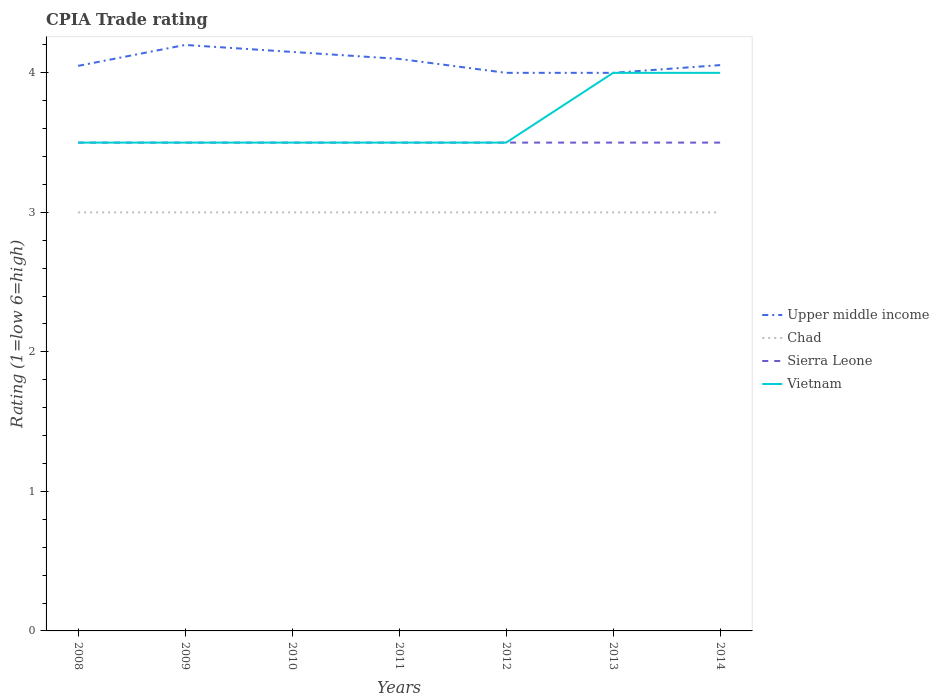Does the line corresponding to Chad intersect with the line corresponding to Upper middle income?
Your response must be concise. No. In which year was the CPIA rating in Upper middle income maximum?
Make the answer very short. 2012. What is the difference between the highest and the second highest CPIA rating in Upper middle income?
Provide a succinct answer. 0.2. What is the difference between the highest and the lowest CPIA rating in Vietnam?
Provide a succinct answer. 2. Is the CPIA rating in Upper middle income strictly greater than the CPIA rating in Chad over the years?
Your answer should be very brief. No. How many lines are there?
Keep it short and to the point. 4. How many years are there in the graph?
Give a very brief answer. 7. What is the difference between two consecutive major ticks on the Y-axis?
Make the answer very short. 1. Are the values on the major ticks of Y-axis written in scientific E-notation?
Offer a terse response. No. How are the legend labels stacked?
Your answer should be very brief. Vertical. What is the title of the graph?
Provide a succinct answer. CPIA Trade rating. Does "Mexico" appear as one of the legend labels in the graph?
Your answer should be compact. No. What is the Rating (1=low 6=high) of Upper middle income in 2008?
Offer a terse response. 4.05. What is the Rating (1=low 6=high) in Vietnam in 2008?
Your response must be concise. 3.5. What is the Rating (1=low 6=high) of Chad in 2009?
Offer a terse response. 3. What is the Rating (1=low 6=high) of Sierra Leone in 2009?
Provide a short and direct response. 3.5. What is the Rating (1=low 6=high) in Upper middle income in 2010?
Ensure brevity in your answer.  4.15. What is the Rating (1=low 6=high) of Sierra Leone in 2010?
Make the answer very short. 3.5. What is the Rating (1=low 6=high) of Vietnam in 2010?
Provide a succinct answer. 3.5. What is the Rating (1=low 6=high) of Chad in 2011?
Give a very brief answer. 3. What is the Rating (1=low 6=high) in Sierra Leone in 2011?
Give a very brief answer. 3.5. What is the Rating (1=low 6=high) in Sierra Leone in 2012?
Provide a short and direct response. 3.5. What is the Rating (1=low 6=high) of Vietnam in 2012?
Your response must be concise. 3.5. What is the Rating (1=low 6=high) of Sierra Leone in 2013?
Your answer should be compact. 3.5. What is the Rating (1=low 6=high) of Upper middle income in 2014?
Ensure brevity in your answer.  4.06. What is the Rating (1=low 6=high) of Chad in 2014?
Your answer should be compact. 3. What is the Rating (1=low 6=high) in Vietnam in 2014?
Ensure brevity in your answer.  4. Across all years, what is the maximum Rating (1=low 6=high) in Upper middle income?
Your answer should be compact. 4.2. Across all years, what is the maximum Rating (1=low 6=high) of Vietnam?
Your response must be concise. 4. Across all years, what is the minimum Rating (1=low 6=high) of Chad?
Your answer should be very brief. 3. Across all years, what is the minimum Rating (1=low 6=high) in Vietnam?
Offer a very short reply. 3.5. What is the total Rating (1=low 6=high) of Upper middle income in the graph?
Provide a short and direct response. 28.56. What is the total Rating (1=low 6=high) in Chad in the graph?
Provide a short and direct response. 21. What is the total Rating (1=low 6=high) of Sierra Leone in the graph?
Your response must be concise. 24.5. What is the total Rating (1=low 6=high) in Vietnam in the graph?
Provide a succinct answer. 25.5. What is the difference between the Rating (1=low 6=high) of Upper middle income in 2008 and that in 2009?
Ensure brevity in your answer.  -0.15. What is the difference between the Rating (1=low 6=high) in Chad in 2008 and that in 2009?
Offer a terse response. 0. What is the difference between the Rating (1=low 6=high) of Upper middle income in 2008 and that in 2011?
Your answer should be compact. -0.05. What is the difference between the Rating (1=low 6=high) of Chad in 2008 and that in 2011?
Your answer should be compact. 0. What is the difference between the Rating (1=low 6=high) in Vietnam in 2008 and that in 2011?
Your answer should be compact. 0. What is the difference between the Rating (1=low 6=high) of Chad in 2008 and that in 2012?
Your response must be concise. 0. What is the difference between the Rating (1=low 6=high) of Upper middle income in 2008 and that in 2014?
Provide a succinct answer. -0.01. What is the difference between the Rating (1=low 6=high) in Vietnam in 2008 and that in 2014?
Keep it short and to the point. -0.5. What is the difference between the Rating (1=low 6=high) of Chad in 2009 and that in 2010?
Offer a terse response. 0. What is the difference between the Rating (1=low 6=high) in Sierra Leone in 2009 and that in 2010?
Make the answer very short. 0. What is the difference between the Rating (1=low 6=high) of Upper middle income in 2009 and that in 2011?
Ensure brevity in your answer.  0.1. What is the difference between the Rating (1=low 6=high) of Vietnam in 2009 and that in 2011?
Your answer should be compact. 0. What is the difference between the Rating (1=low 6=high) in Upper middle income in 2009 and that in 2012?
Your answer should be compact. 0.2. What is the difference between the Rating (1=low 6=high) of Chad in 2009 and that in 2012?
Offer a very short reply. 0. What is the difference between the Rating (1=low 6=high) of Vietnam in 2009 and that in 2012?
Provide a succinct answer. 0. What is the difference between the Rating (1=low 6=high) in Upper middle income in 2009 and that in 2013?
Offer a very short reply. 0.2. What is the difference between the Rating (1=low 6=high) in Chad in 2009 and that in 2013?
Offer a terse response. 0. What is the difference between the Rating (1=low 6=high) of Sierra Leone in 2009 and that in 2013?
Make the answer very short. 0. What is the difference between the Rating (1=low 6=high) of Vietnam in 2009 and that in 2013?
Give a very brief answer. -0.5. What is the difference between the Rating (1=low 6=high) of Upper middle income in 2009 and that in 2014?
Ensure brevity in your answer.  0.14. What is the difference between the Rating (1=low 6=high) of Chad in 2009 and that in 2014?
Ensure brevity in your answer.  0. What is the difference between the Rating (1=low 6=high) in Chad in 2010 and that in 2011?
Offer a terse response. 0. What is the difference between the Rating (1=low 6=high) of Sierra Leone in 2010 and that in 2011?
Offer a terse response. 0. What is the difference between the Rating (1=low 6=high) of Vietnam in 2010 and that in 2011?
Give a very brief answer. 0. What is the difference between the Rating (1=low 6=high) in Vietnam in 2010 and that in 2012?
Your response must be concise. 0. What is the difference between the Rating (1=low 6=high) of Sierra Leone in 2010 and that in 2013?
Provide a short and direct response. 0. What is the difference between the Rating (1=low 6=high) of Vietnam in 2010 and that in 2013?
Provide a short and direct response. -0.5. What is the difference between the Rating (1=low 6=high) of Upper middle income in 2010 and that in 2014?
Your answer should be very brief. 0.09. What is the difference between the Rating (1=low 6=high) of Sierra Leone in 2010 and that in 2014?
Make the answer very short. 0. What is the difference between the Rating (1=low 6=high) of Vietnam in 2010 and that in 2014?
Your answer should be very brief. -0.5. What is the difference between the Rating (1=low 6=high) of Upper middle income in 2011 and that in 2012?
Offer a very short reply. 0.1. What is the difference between the Rating (1=low 6=high) in Chad in 2011 and that in 2013?
Ensure brevity in your answer.  0. What is the difference between the Rating (1=low 6=high) in Upper middle income in 2011 and that in 2014?
Offer a very short reply. 0.04. What is the difference between the Rating (1=low 6=high) of Chad in 2011 and that in 2014?
Your response must be concise. 0. What is the difference between the Rating (1=low 6=high) in Sierra Leone in 2011 and that in 2014?
Provide a short and direct response. 0. What is the difference between the Rating (1=low 6=high) in Vietnam in 2011 and that in 2014?
Keep it short and to the point. -0.5. What is the difference between the Rating (1=low 6=high) of Upper middle income in 2012 and that in 2013?
Provide a succinct answer. 0. What is the difference between the Rating (1=low 6=high) of Chad in 2012 and that in 2013?
Your answer should be compact. 0. What is the difference between the Rating (1=low 6=high) in Sierra Leone in 2012 and that in 2013?
Give a very brief answer. 0. What is the difference between the Rating (1=low 6=high) of Upper middle income in 2012 and that in 2014?
Provide a short and direct response. -0.06. What is the difference between the Rating (1=low 6=high) of Upper middle income in 2013 and that in 2014?
Offer a terse response. -0.06. What is the difference between the Rating (1=low 6=high) of Chad in 2013 and that in 2014?
Make the answer very short. 0. What is the difference between the Rating (1=low 6=high) in Sierra Leone in 2013 and that in 2014?
Offer a terse response. 0. What is the difference between the Rating (1=low 6=high) in Vietnam in 2013 and that in 2014?
Your answer should be very brief. 0. What is the difference between the Rating (1=low 6=high) of Upper middle income in 2008 and the Rating (1=low 6=high) of Chad in 2009?
Provide a short and direct response. 1.05. What is the difference between the Rating (1=low 6=high) of Upper middle income in 2008 and the Rating (1=low 6=high) of Sierra Leone in 2009?
Provide a short and direct response. 0.55. What is the difference between the Rating (1=low 6=high) of Upper middle income in 2008 and the Rating (1=low 6=high) of Vietnam in 2009?
Provide a short and direct response. 0.55. What is the difference between the Rating (1=low 6=high) in Upper middle income in 2008 and the Rating (1=low 6=high) in Chad in 2010?
Offer a terse response. 1.05. What is the difference between the Rating (1=low 6=high) in Upper middle income in 2008 and the Rating (1=low 6=high) in Sierra Leone in 2010?
Offer a very short reply. 0.55. What is the difference between the Rating (1=low 6=high) in Upper middle income in 2008 and the Rating (1=low 6=high) in Vietnam in 2010?
Give a very brief answer. 0.55. What is the difference between the Rating (1=low 6=high) of Upper middle income in 2008 and the Rating (1=low 6=high) of Sierra Leone in 2011?
Provide a succinct answer. 0.55. What is the difference between the Rating (1=low 6=high) of Upper middle income in 2008 and the Rating (1=low 6=high) of Vietnam in 2011?
Offer a terse response. 0.55. What is the difference between the Rating (1=low 6=high) in Chad in 2008 and the Rating (1=low 6=high) in Sierra Leone in 2011?
Provide a short and direct response. -0.5. What is the difference between the Rating (1=low 6=high) of Upper middle income in 2008 and the Rating (1=low 6=high) of Sierra Leone in 2012?
Your answer should be compact. 0.55. What is the difference between the Rating (1=low 6=high) in Upper middle income in 2008 and the Rating (1=low 6=high) in Vietnam in 2012?
Offer a very short reply. 0.55. What is the difference between the Rating (1=low 6=high) of Chad in 2008 and the Rating (1=low 6=high) of Sierra Leone in 2012?
Your answer should be compact. -0.5. What is the difference between the Rating (1=low 6=high) of Upper middle income in 2008 and the Rating (1=low 6=high) of Sierra Leone in 2013?
Make the answer very short. 0.55. What is the difference between the Rating (1=low 6=high) in Upper middle income in 2008 and the Rating (1=low 6=high) in Vietnam in 2013?
Your answer should be very brief. 0.05. What is the difference between the Rating (1=low 6=high) of Chad in 2008 and the Rating (1=low 6=high) of Sierra Leone in 2013?
Your answer should be very brief. -0.5. What is the difference between the Rating (1=low 6=high) in Chad in 2008 and the Rating (1=low 6=high) in Vietnam in 2013?
Your response must be concise. -1. What is the difference between the Rating (1=low 6=high) of Upper middle income in 2008 and the Rating (1=low 6=high) of Sierra Leone in 2014?
Make the answer very short. 0.55. What is the difference between the Rating (1=low 6=high) of Chad in 2008 and the Rating (1=low 6=high) of Sierra Leone in 2014?
Ensure brevity in your answer.  -0.5. What is the difference between the Rating (1=low 6=high) in Sierra Leone in 2008 and the Rating (1=low 6=high) in Vietnam in 2014?
Provide a short and direct response. -0.5. What is the difference between the Rating (1=low 6=high) in Upper middle income in 2009 and the Rating (1=low 6=high) in Sierra Leone in 2010?
Ensure brevity in your answer.  0.7. What is the difference between the Rating (1=low 6=high) of Chad in 2009 and the Rating (1=low 6=high) of Sierra Leone in 2010?
Your answer should be compact. -0.5. What is the difference between the Rating (1=low 6=high) in Chad in 2009 and the Rating (1=low 6=high) in Vietnam in 2010?
Your answer should be compact. -0.5. What is the difference between the Rating (1=low 6=high) of Upper middle income in 2009 and the Rating (1=low 6=high) of Chad in 2011?
Keep it short and to the point. 1.2. What is the difference between the Rating (1=low 6=high) in Upper middle income in 2009 and the Rating (1=low 6=high) in Sierra Leone in 2011?
Your response must be concise. 0.7. What is the difference between the Rating (1=low 6=high) in Sierra Leone in 2009 and the Rating (1=low 6=high) in Vietnam in 2011?
Provide a short and direct response. 0. What is the difference between the Rating (1=low 6=high) of Upper middle income in 2009 and the Rating (1=low 6=high) of Vietnam in 2012?
Your answer should be very brief. 0.7. What is the difference between the Rating (1=low 6=high) of Chad in 2009 and the Rating (1=low 6=high) of Vietnam in 2012?
Make the answer very short. -0.5. What is the difference between the Rating (1=low 6=high) of Sierra Leone in 2009 and the Rating (1=low 6=high) of Vietnam in 2012?
Your answer should be compact. 0. What is the difference between the Rating (1=low 6=high) of Upper middle income in 2009 and the Rating (1=low 6=high) of Sierra Leone in 2013?
Make the answer very short. 0.7. What is the difference between the Rating (1=low 6=high) of Upper middle income in 2009 and the Rating (1=low 6=high) of Vietnam in 2013?
Offer a terse response. 0.2. What is the difference between the Rating (1=low 6=high) of Sierra Leone in 2009 and the Rating (1=low 6=high) of Vietnam in 2013?
Give a very brief answer. -0.5. What is the difference between the Rating (1=low 6=high) in Upper middle income in 2009 and the Rating (1=low 6=high) in Sierra Leone in 2014?
Your response must be concise. 0.7. What is the difference between the Rating (1=low 6=high) of Upper middle income in 2010 and the Rating (1=low 6=high) of Chad in 2011?
Offer a terse response. 1.15. What is the difference between the Rating (1=low 6=high) of Upper middle income in 2010 and the Rating (1=low 6=high) of Sierra Leone in 2011?
Give a very brief answer. 0.65. What is the difference between the Rating (1=low 6=high) of Upper middle income in 2010 and the Rating (1=low 6=high) of Vietnam in 2011?
Provide a succinct answer. 0.65. What is the difference between the Rating (1=low 6=high) of Chad in 2010 and the Rating (1=low 6=high) of Vietnam in 2011?
Keep it short and to the point. -0.5. What is the difference between the Rating (1=low 6=high) in Upper middle income in 2010 and the Rating (1=low 6=high) in Chad in 2012?
Keep it short and to the point. 1.15. What is the difference between the Rating (1=low 6=high) of Upper middle income in 2010 and the Rating (1=low 6=high) of Sierra Leone in 2012?
Provide a short and direct response. 0.65. What is the difference between the Rating (1=low 6=high) in Upper middle income in 2010 and the Rating (1=low 6=high) in Vietnam in 2012?
Provide a short and direct response. 0.65. What is the difference between the Rating (1=low 6=high) of Upper middle income in 2010 and the Rating (1=low 6=high) of Chad in 2013?
Your response must be concise. 1.15. What is the difference between the Rating (1=low 6=high) of Upper middle income in 2010 and the Rating (1=low 6=high) of Sierra Leone in 2013?
Provide a short and direct response. 0.65. What is the difference between the Rating (1=low 6=high) of Upper middle income in 2010 and the Rating (1=low 6=high) of Chad in 2014?
Offer a very short reply. 1.15. What is the difference between the Rating (1=low 6=high) of Upper middle income in 2010 and the Rating (1=low 6=high) of Sierra Leone in 2014?
Ensure brevity in your answer.  0.65. What is the difference between the Rating (1=low 6=high) in Upper middle income in 2010 and the Rating (1=low 6=high) in Vietnam in 2014?
Your answer should be compact. 0.15. What is the difference between the Rating (1=low 6=high) of Chad in 2010 and the Rating (1=low 6=high) of Vietnam in 2014?
Provide a succinct answer. -1. What is the difference between the Rating (1=low 6=high) of Upper middle income in 2011 and the Rating (1=low 6=high) of Vietnam in 2012?
Your answer should be very brief. 0.6. What is the difference between the Rating (1=low 6=high) in Upper middle income in 2011 and the Rating (1=low 6=high) in Chad in 2013?
Ensure brevity in your answer.  1.1. What is the difference between the Rating (1=low 6=high) in Upper middle income in 2011 and the Rating (1=low 6=high) in Sierra Leone in 2013?
Your answer should be compact. 0.6. What is the difference between the Rating (1=low 6=high) of Chad in 2011 and the Rating (1=low 6=high) of Sierra Leone in 2013?
Your response must be concise. -0.5. What is the difference between the Rating (1=low 6=high) of Chad in 2011 and the Rating (1=low 6=high) of Vietnam in 2013?
Offer a very short reply. -1. What is the difference between the Rating (1=low 6=high) of Upper middle income in 2011 and the Rating (1=low 6=high) of Chad in 2014?
Your response must be concise. 1.1. What is the difference between the Rating (1=low 6=high) of Upper middle income in 2011 and the Rating (1=low 6=high) of Vietnam in 2014?
Ensure brevity in your answer.  0.1. What is the difference between the Rating (1=low 6=high) in Chad in 2011 and the Rating (1=low 6=high) in Vietnam in 2014?
Your answer should be very brief. -1. What is the difference between the Rating (1=low 6=high) of Upper middle income in 2012 and the Rating (1=low 6=high) of Sierra Leone in 2013?
Your response must be concise. 0.5. What is the difference between the Rating (1=low 6=high) in Upper middle income in 2012 and the Rating (1=low 6=high) in Vietnam in 2013?
Keep it short and to the point. 0. What is the difference between the Rating (1=low 6=high) of Chad in 2012 and the Rating (1=low 6=high) of Sierra Leone in 2013?
Make the answer very short. -0.5. What is the difference between the Rating (1=low 6=high) of Sierra Leone in 2012 and the Rating (1=low 6=high) of Vietnam in 2013?
Provide a succinct answer. -0.5. What is the difference between the Rating (1=low 6=high) in Upper middle income in 2012 and the Rating (1=low 6=high) in Chad in 2014?
Ensure brevity in your answer.  1. What is the difference between the Rating (1=low 6=high) of Upper middle income in 2012 and the Rating (1=low 6=high) of Sierra Leone in 2014?
Offer a very short reply. 0.5. What is the difference between the Rating (1=low 6=high) in Upper middle income in 2012 and the Rating (1=low 6=high) in Vietnam in 2014?
Make the answer very short. 0. What is the difference between the Rating (1=low 6=high) in Chad in 2012 and the Rating (1=low 6=high) in Sierra Leone in 2014?
Your answer should be compact. -0.5. What is the difference between the Rating (1=low 6=high) of Upper middle income in 2013 and the Rating (1=low 6=high) of Sierra Leone in 2014?
Your answer should be very brief. 0.5. What is the difference between the Rating (1=low 6=high) in Chad in 2013 and the Rating (1=low 6=high) in Vietnam in 2014?
Your answer should be compact. -1. What is the average Rating (1=low 6=high) in Upper middle income per year?
Ensure brevity in your answer.  4.08. What is the average Rating (1=low 6=high) of Sierra Leone per year?
Give a very brief answer. 3.5. What is the average Rating (1=low 6=high) in Vietnam per year?
Give a very brief answer. 3.64. In the year 2008, what is the difference between the Rating (1=low 6=high) in Upper middle income and Rating (1=low 6=high) in Chad?
Offer a very short reply. 1.05. In the year 2008, what is the difference between the Rating (1=low 6=high) of Upper middle income and Rating (1=low 6=high) of Sierra Leone?
Keep it short and to the point. 0.55. In the year 2008, what is the difference between the Rating (1=low 6=high) of Upper middle income and Rating (1=low 6=high) of Vietnam?
Keep it short and to the point. 0.55. In the year 2009, what is the difference between the Rating (1=low 6=high) in Upper middle income and Rating (1=low 6=high) in Chad?
Offer a terse response. 1.2. In the year 2009, what is the difference between the Rating (1=low 6=high) in Upper middle income and Rating (1=low 6=high) in Vietnam?
Give a very brief answer. 0.7. In the year 2010, what is the difference between the Rating (1=low 6=high) of Upper middle income and Rating (1=low 6=high) of Chad?
Give a very brief answer. 1.15. In the year 2010, what is the difference between the Rating (1=low 6=high) in Upper middle income and Rating (1=low 6=high) in Sierra Leone?
Give a very brief answer. 0.65. In the year 2010, what is the difference between the Rating (1=low 6=high) in Upper middle income and Rating (1=low 6=high) in Vietnam?
Make the answer very short. 0.65. In the year 2010, what is the difference between the Rating (1=low 6=high) in Sierra Leone and Rating (1=low 6=high) in Vietnam?
Ensure brevity in your answer.  0. In the year 2011, what is the difference between the Rating (1=low 6=high) of Upper middle income and Rating (1=low 6=high) of Sierra Leone?
Your answer should be very brief. 0.6. In the year 2011, what is the difference between the Rating (1=low 6=high) in Upper middle income and Rating (1=low 6=high) in Vietnam?
Offer a very short reply. 0.6. In the year 2011, what is the difference between the Rating (1=low 6=high) of Chad and Rating (1=low 6=high) of Vietnam?
Provide a succinct answer. -0.5. In the year 2012, what is the difference between the Rating (1=low 6=high) of Upper middle income and Rating (1=low 6=high) of Chad?
Keep it short and to the point. 1. In the year 2012, what is the difference between the Rating (1=low 6=high) of Upper middle income and Rating (1=low 6=high) of Vietnam?
Provide a short and direct response. 0.5. In the year 2012, what is the difference between the Rating (1=low 6=high) in Chad and Rating (1=low 6=high) in Vietnam?
Make the answer very short. -0.5. In the year 2012, what is the difference between the Rating (1=low 6=high) of Sierra Leone and Rating (1=low 6=high) of Vietnam?
Provide a short and direct response. 0. In the year 2013, what is the difference between the Rating (1=low 6=high) of Upper middle income and Rating (1=low 6=high) of Chad?
Keep it short and to the point. 1. In the year 2014, what is the difference between the Rating (1=low 6=high) in Upper middle income and Rating (1=low 6=high) in Chad?
Offer a terse response. 1.06. In the year 2014, what is the difference between the Rating (1=low 6=high) of Upper middle income and Rating (1=low 6=high) of Sierra Leone?
Your answer should be very brief. 0.56. In the year 2014, what is the difference between the Rating (1=low 6=high) of Upper middle income and Rating (1=low 6=high) of Vietnam?
Your answer should be compact. 0.06. What is the ratio of the Rating (1=low 6=high) in Upper middle income in 2008 to that in 2010?
Offer a terse response. 0.98. What is the ratio of the Rating (1=low 6=high) in Sierra Leone in 2008 to that in 2010?
Keep it short and to the point. 1. What is the ratio of the Rating (1=low 6=high) of Chad in 2008 to that in 2011?
Give a very brief answer. 1. What is the ratio of the Rating (1=low 6=high) in Sierra Leone in 2008 to that in 2011?
Give a very brief answer. 1. What is the ratio of the Rating (1=low 6=high) of Vietnam in 2008 to that in 2011?
Give a very brief answer. 1. What is the ratio of the Rating (1=low 6=high) of Upper middle income in 2008 to that in 2012?
Keep it short and to the point. 1.01. What is the ratio of the Rating (1=low 6=high) in Chad in 2008 to that in 2012?
Ensure brevity in your answer.  1. What is the ratio of the Rating (1=low 6=high) in Upper middle income in 2008 to that in 2013?
Offer a terse response. 1.01. What is the ratio of the Rating (1=low 6=high) in Chad in 2008 to that in 2013?
Your answer should be compact. 1. What is the ratio of the Rating (1=low 6=high) in Sierra Leone in 2008 to that in 2013?
Your answer should be very brief. 1. What is the ratio of the Rating (1=low 6=high) of Sierra Leone in 2008 to that in 2014?
Make the answer very short. 1. What is the ratio of the Rating (1=low 6=high) of Vietnam in 2008 to that in 2014?
Keep it short and to the point. 0.88. What is the ratio of the Rating (1=low 6=high) in Upper middle income in 2009 to that in 2010?
Keep it short and to the point. 1.01. What is the ratio of the Rating (1=low 6=high) of Chad in 2009 to that in 2010?
Make the answer very short. 1. What is the ratio of the Rating (1=low 6=high) in Vietnam in 2009 to that in 2010?
Keep it short and to the point. 1. What is the ratio of the Rating (1=low 6=high) in Upper middle income in 2009 to that in 2011?
Provide a succinct answer. 1.02. What is the ratio of the Rating (1=low 6=high) in Sierra Leone in 2009 to that in 2011?
Give a very brief answer. 1. What is the ratio of the Rating (1=low 6=high) of Vietnam in 2009 to that in 2011?
Your answer should be very brief. 1. What is the ratio of the Rating (1=low 6=high) in Upper middle income in 2009 to that in 2012?
Make the answer very short. 1.05. What is the ratio of the Rating (1=low 6=high) of Vietnam in 2009 to that in 2013?
Ensure brevity in your answer.  0.88. What is the ratio of the Rating (1=low 6=high) of Upper middle income in 2009 to that in 2014?
Offer a very short reply. 1.04. What is the ratio of the Rating (1=low 6=high) of Vietnam in 2009 to that in 2014?
Your answer should be very brief. 0.88. What is the ratio of the Rating (1=low 6=high) in Upper middle income in 2010 to that in 2011?
Offer a very short reply. 1.01. What is the ratio of the Rating (1=low 6=high) in Chad in 2010 to that in 2011?
Make the answer very short. 1. What is the ratio of the Rating (1=low 6=high) in Upper middle income in 2010 to that in 2012?
Your answer should be compact. 1.04. What is the ratio of the Rating (1=low 6=high) in Chad in 2010 to that in 2012?
Your answer should be compact. 1. What is the ratio of the Rating (1=low 6=high) in Upper middle income in 2010 to that in 2013?
Provide a short and direct response. 1.04. What is the ratio of the Rating (1=low 6=high) of Chad in 2010 to that in 2013?
Offer a very short reply. 1. What is the ratio of the Rating (1=low 6=high) of Sierra Leone in 2010 to that in 2013?
Offer a very short reply. 1. What is the ratio of the Rating (1=low 6=high) in Upper middle income in 2010 to that in 2014?
Keep it short and to the point. 1.02. What is the ratio of the Rating (1=low 6=high) of Chad in 2010 to that in 2014?
Give a very brief answer. 1. What is the ratio of the Rating (1=low 6=high) of Chad in 2011 to that in 2012?
Provide a succinct answer. 1. What is the ratio of the Rating (1=low 6=high) in Sierra Leone in 2011 to that in 2012?
Provide a succinct answer. 1. What is the ratio of the Rating (1=low 6=high) of Vietnam in 2011 to that in 2012?
Your answer should be compact. 1. What is the ratio of the Rating (1=low 6=high) in Upper middle income in 2011 to that in 2013?
Provide a succinct answer. 1.02. What is the ratio of the Rating (1=low 6=high) of Sierra Leone in 2011 to that in 2013?
Provide a succinct answer. 1. What is the ratio of the Rating (1=low 6=high) in Upper middle income in 2011 to that in 2014?
Your response must be concise. 1.01. What is the ratio of the Rating (1=low 6=high) in Sierra Leone in 2011 to that in 2014?
Keep it short and to the point. 1. What is the ratio of the Rating (1=low 6=high) of Sierra Leone in 2012 to that in 2013?
Give a very brief answer. 1. What is the ratio of the Rating (1=low 6=high) in Upper middle income in 2012 to that in 2014?
Offer a terse response. 0.99. What is the ratio of the Rating (1=low 6=high) in Vietnam in 2012 to that in 2014?
Your response must be concise. 0.88. What is the ratio of the Rating (1=low 6=high) in Upper middle income in 2013 to that in 2014?
Provide a succinct answer. 0.99. What is the ratio of the Rating (1=low 6=high) in Vietnam in 2013 to that in 2014?
Provide a short and direct response. 1. What is the difference between the highest and the second highest Rating (1=low 6=high) of Upper middle income?
Keep it short and to the point. 0.05. What is the difference between the highest and the second highest Rating (1=low 6=high) of Chad?
Provide a succinct answer. 0. What is the difference between the highest and the second highest Rating (1=low 6=high) of Sierra Leone?
Ensure brevity in your answer.  0. What is the difference between the highest and the second highest Rating (1=low 6=high) in Vietnam?
Offer a terse response. 0. What is the difference between the highest and the lowest Rating (1=low 6=high) of Upper middle income?
Your answer should be compact. 0.2. 